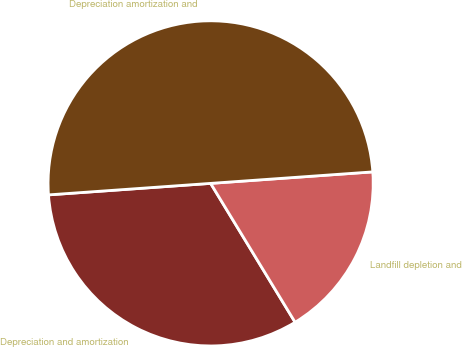Convert chart to OTSL. <chart><loc_0><loc_0><loc_500><loc_500><pie_chart><fcel>Depreciation and amortization<fcel>Landfill depletion and<fcel>Depreciation amortization and<nl><fcel>32.57%<fcel>17.43%<fcel>50.0%<nl></chart> 